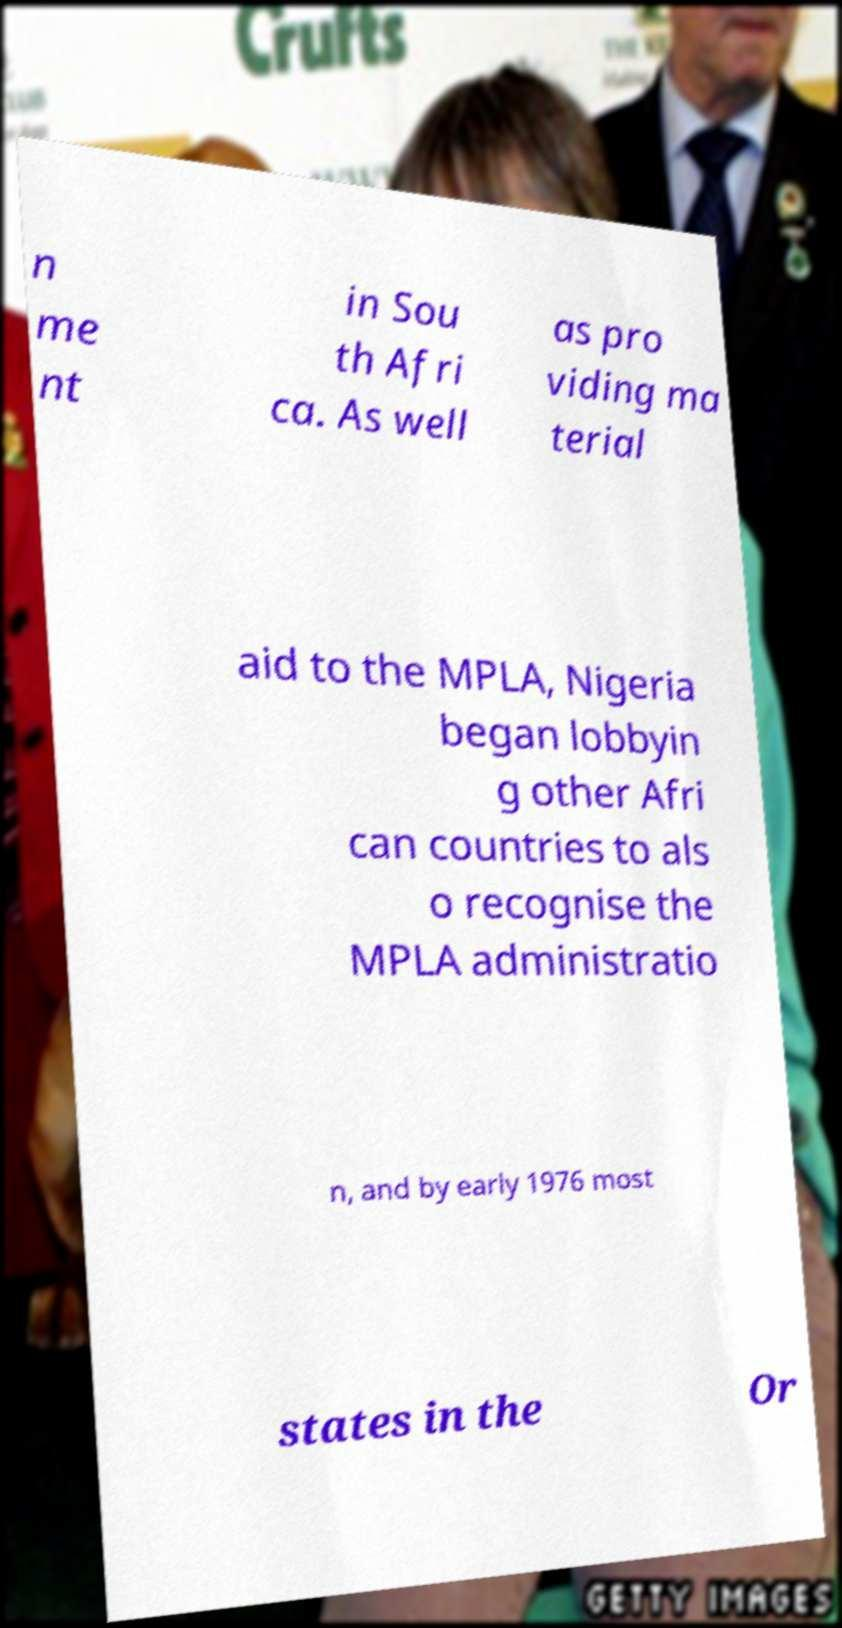Could you assist in decoding the text presented in this image and type it out clearly? n me nt in Sou th Afri ca. As well as pro viding ma terial aid to the MPLA, Nigeria began lobbyin g other Afri can countries to als o recognise the MPLA administratio n, and by early 1976 most states in the Or 